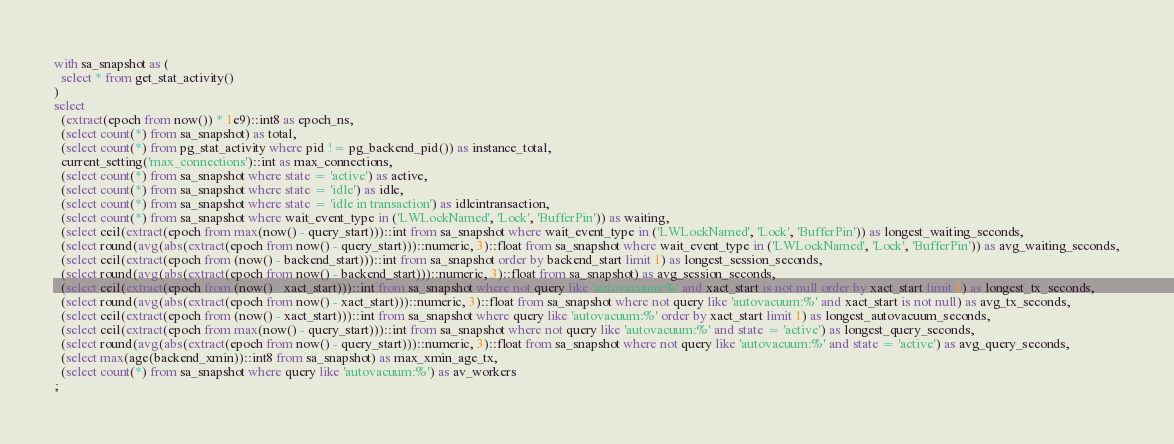<code> <loc_0><loc_0><loc_500><loc_500><_SQL_>with sa_snapshot as (
  select * from get_stat_activity()
)
select
  (extract(epoch from now()) * 1e9)::int8 as epoch_ns,
  (select count(*) from sa_snapshot) as total,
  (select count(*) from pg_stat_activity where pid != pg_backend_pid()) as instance_total,
  current_setting('max_connections')::int as max_connections,
  (select count(*) from sa_snapshot where state = 'active') as active,
  (select count(*) from sa_snapshot where state = 'idle') as idle,
  (select count(*) from sa_snapshot where state = 'idle in transaction') as idleintransaction,
  (select count(*) from sa_snapshot where wait_event_type in ('LWLockNamed', 'Lock', 'BufferPin')) as waiting,
  (select ceil(extract(epoch from max(now() - query_start)))::int from sa_snapshot where wait_event_type in ('LWLockNamed', 'Lock', 'BufferPin')) as longest_waiting_seconds,
  (select round(avg(abs(extract(epoch from now() - query_start)))::numeric, 3)::float from sa_snapshot where wait_event_type in ('LWLockNamed', 'Lock', 'BufferPin')) as avg_waiting_seconds,
  (select ceil(extract(epoch from (now() - backend_start)))::int from sa_snapshot order by backend_start limit 1) as longest_session_seconds,
  (select round(avg(abs(extract(epoch from now() - backend_start)))::numeric, 3)::float from sa_snapshot) as avg_session_seconds,
  (select ceil(extract(epoch from (now() - xact_start)))::int from sa_snapshot where not query like 'autovacuum:%' and xact_start is not null order by xact_start limit 1) as longest_tx_seconds,
  (select round(avg(abs(extract(epoch from now() - xact_start)))::numeric, 3)::float from sa_snapshot where not query like 'autovacuum:%' and xact_start is not null) as avg_tx_seconds,
  (select ceil(extract(epoch from (now() - xact_start)))::int from sa_snapshot where query like 'autovacuum:%' order by xact_start limit 1) as longest_autovacuum_seconds,
  (select ceil(extract(epoch from max(now() - query_start)))::int from sa_snapshot where not query like 'autovacuum:%' and state = 'active') as longest_query_seconds,
  (select round(avg(abs(extract(epoch from now() - query_start)))::numeric, 3)::float from sa_snapshot where not query like 'autovacuum:%' and state = 'active') as avg_query_seconds,
  (select max(age(backend_xmin))::int8 from sa_snapshot) as max_xmin_age_tx,
  (select count(*) from sa_snapshot where query like 'autovacuum:%') as av_workers
;</code> 